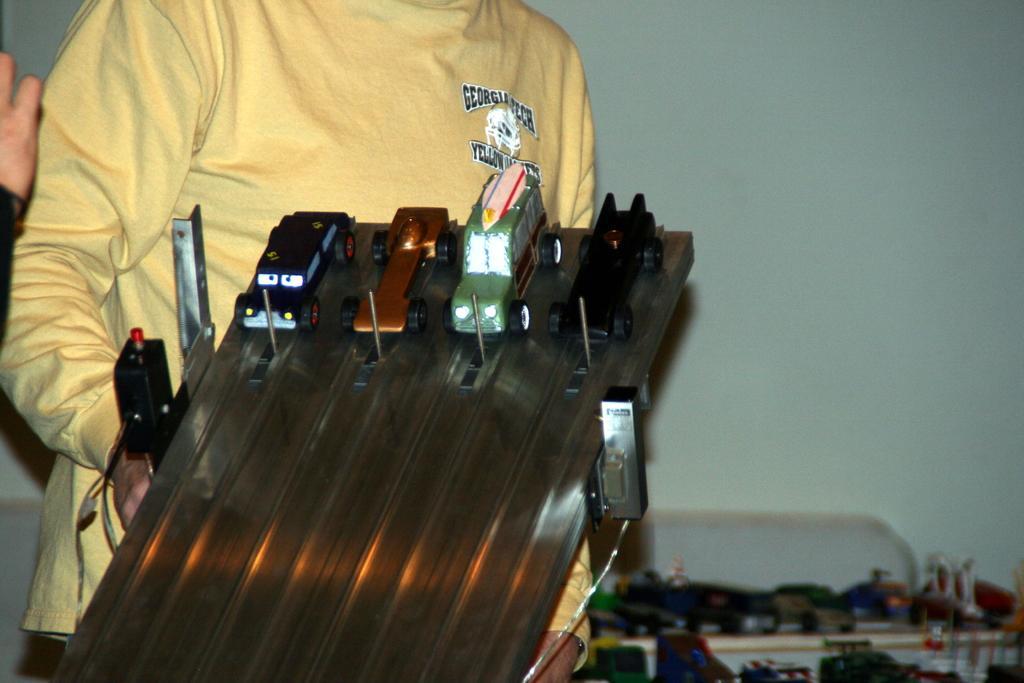Please provide a concise description of this image. This picture might be taken inside the room. In this image, on the left side, we can see a person wearing a yellow color shirt and he is holding a electronic instrument, we can also see hand of a person. On the right side there is a table, on that table, we can see electrical instruments. In the background, we can see a wall which is in white color. 